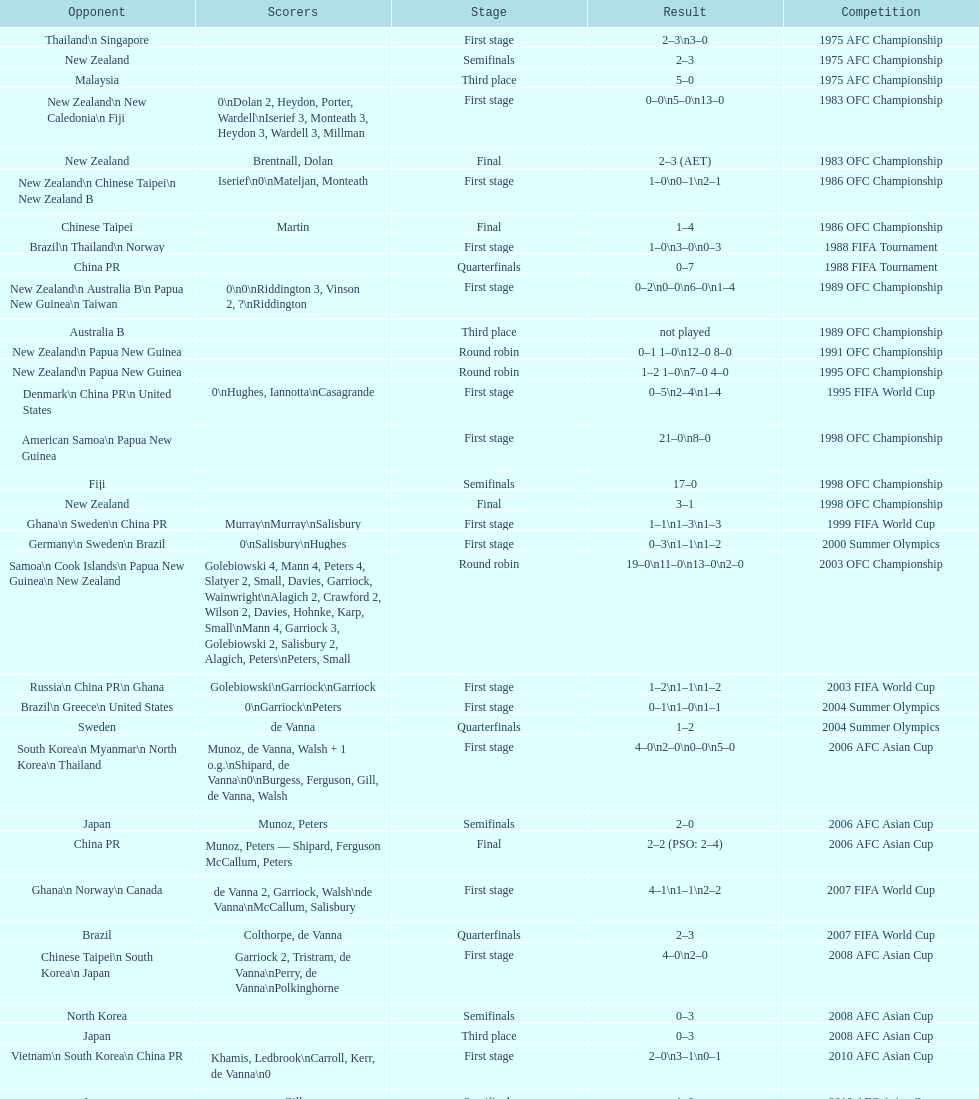Who was this team's next opponent after facing new zealand in the first stage of the 1986 ofc championship? Chinese Taipei. 